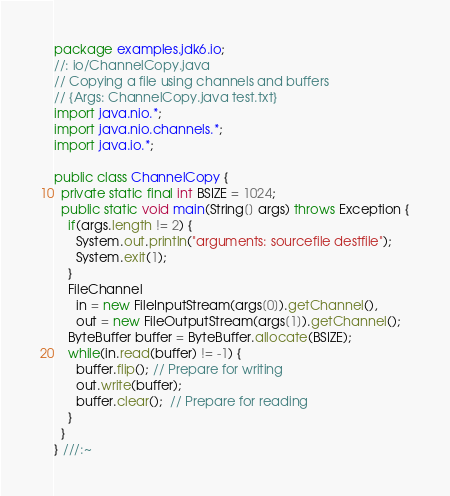<code> <loc_0><loc_0><loc_500><loc_500><_Java_>package examples.jdk6.io;
//: io/ChannelCopy.java
// Copying a file using channels and buffers
// {Args: ChannelCopy.java test.txt}
import java.nio.*;
import java.nio.channels.*;
import java.io.*;

public class ChannelCopy {
  private static final int BSIZE = 1024;
  public static void main(String[] args) throws Exception {
    if(args.length != 2) {
      System.out.println("arguments: sourcefile destfile");
      System.exit(1);
    }
    FileChannel
      in = new FileInputStream(args[0]).getChannel(),
      out = new FileOutputStream(args[1]).getChannel();
    ByteBuffer buffer = ByteBuffer.allocate(BSIZE);
    while(in.read(buffer) != -1) {
      buffer.flip(); // Prepare for writing
      out.write(buffer);
      buffer.clear();  // Prepare for reading
    }
  }
} ///:~
</code> 